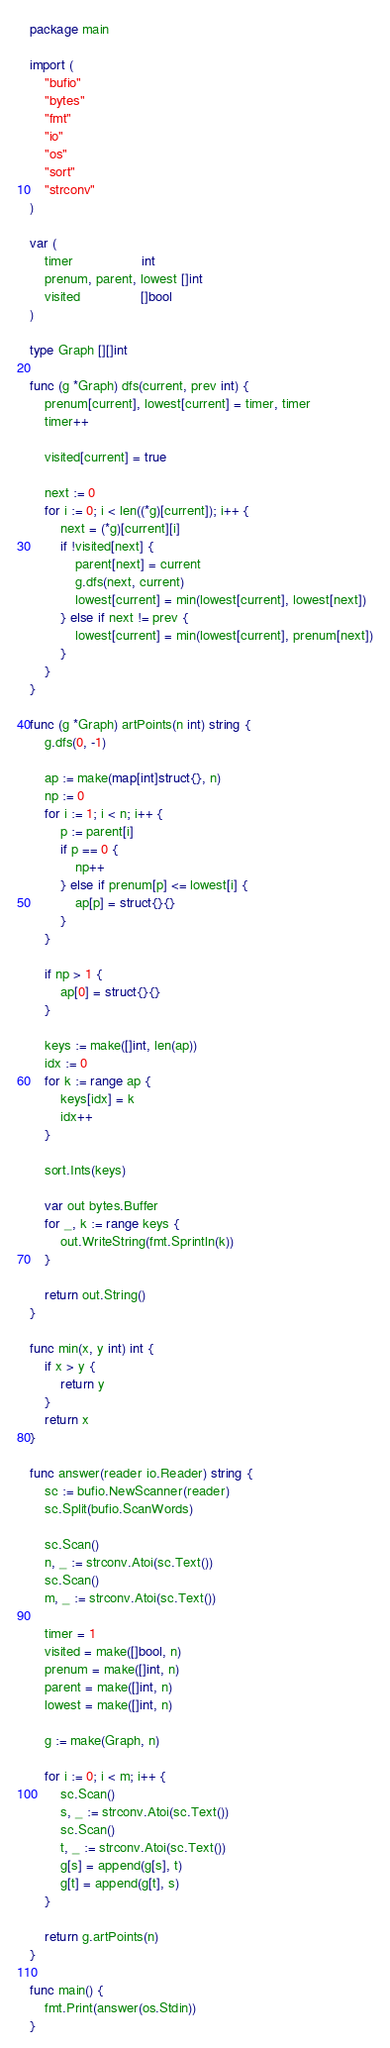<code> <loc_0><loc_0><loc_500><loc_500><_Go_>package main

import (
	"bufio"
	"bytes"
	"fmt"
	"io"
	"os"
	"sort"
	"strconv"
)

var (
	timer                  int
	prenum, parent, lowest []int
	visited                []bool
)

type Graph [][]int

func (g *Graph) dfs(current, prev int) {
	prenum[current], lowest[current] = timer, timer
	timer++

	visited[current] = true

	next := 0
	for i := 0; i < len((*g)[current]); i++ {
		next = (*g)[current][i]
		if !visited[next] {
			parent[next] = current
			g.dfs(next, current)
			lowest[current] = min(lowest[current], lowest[next])
		} else if next != prev {
			lowest[current] = min(lowest[current], prenum[next])
		}
	}
}

func (g *Graph) artPoints(n int) string {
	g.dfs(0, -1)

	ap := make(map[int]struct{}, n)
	np := 0
	for i := 1; i < n; i++ {
		p := parent[i]
		if p == 0 {
			np++
		} else if prenum[p] <= lowest[i] {
			ap[p] = struct{}{}
		}
	}

	if np > 1 {
		ap[0] = struct{}{}
	}

	keys := make([]int, len(ap))
	idx := 0
	for k := range ap {
		keys[idx] = k
		idx++
	}

	sort.Ints(keys)

	var out bytes.Buffer
	for _, k := range keys {
		out.WriteString(fmt.Sprintln(k))
	}

	return out.String()
}

func min(x, y int) int {
	if x > y {
		return y
	}
	return x
}

func answer(reader io.Reader) string {
	sc := bufio.NewScanner(reader)
	sc.Split(bufio.ScanWords)

	sc.Scan()
	n, _ := strconv.Atoi(sc.Text())
	sc.Scan()
	m, _ := strconv.Atoi(sc.Text())

	timer = 1
	visited = make([]bool, n)
	prenum = make([]int, n)
	parent = make([]int, n)
	lowest = make([]int, n)

	g := make(Graph, n)

	for i := 0; i < m; i++ {
		sc.Scan()
		s, _ := strconv.Atoi(sc.Text())
		sc.Scan()
		t, _ := strconv.Atoi(sc.Text())
		g[s] = append(g[s], t)
		g[t] = append(g[t], s)
	}

	return g.artPoints(n)
}

func main() {
	fmt.Print(answer(os.Stdin))
}

</code> 